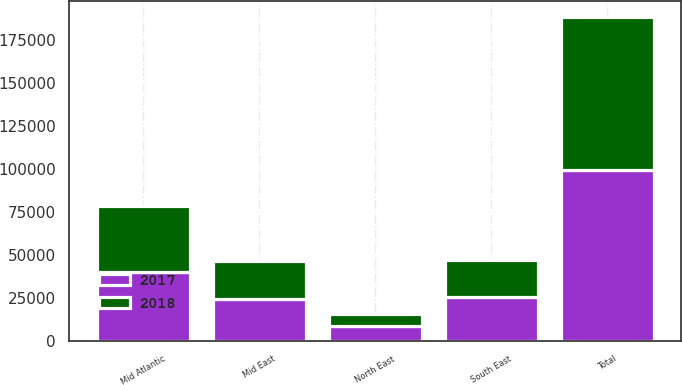Convert chart to OTSL. <chart><loc_0><loc_0><loc_500><loc_500><stacked_bar_chart><ecel><fcel>Mid Atlantic<fcel>North East<fcel>Mid East<fcel>South East<fcel>Total<nl><fcel>2017<fcel>40350<fcel>8950<fcel>24350<fcel>26050<fcel>99700<nl><fcel>2018<fcel>38450<fcel>7000<fcel>22250<fcel>21000<fcel>88700<nl></chart> 